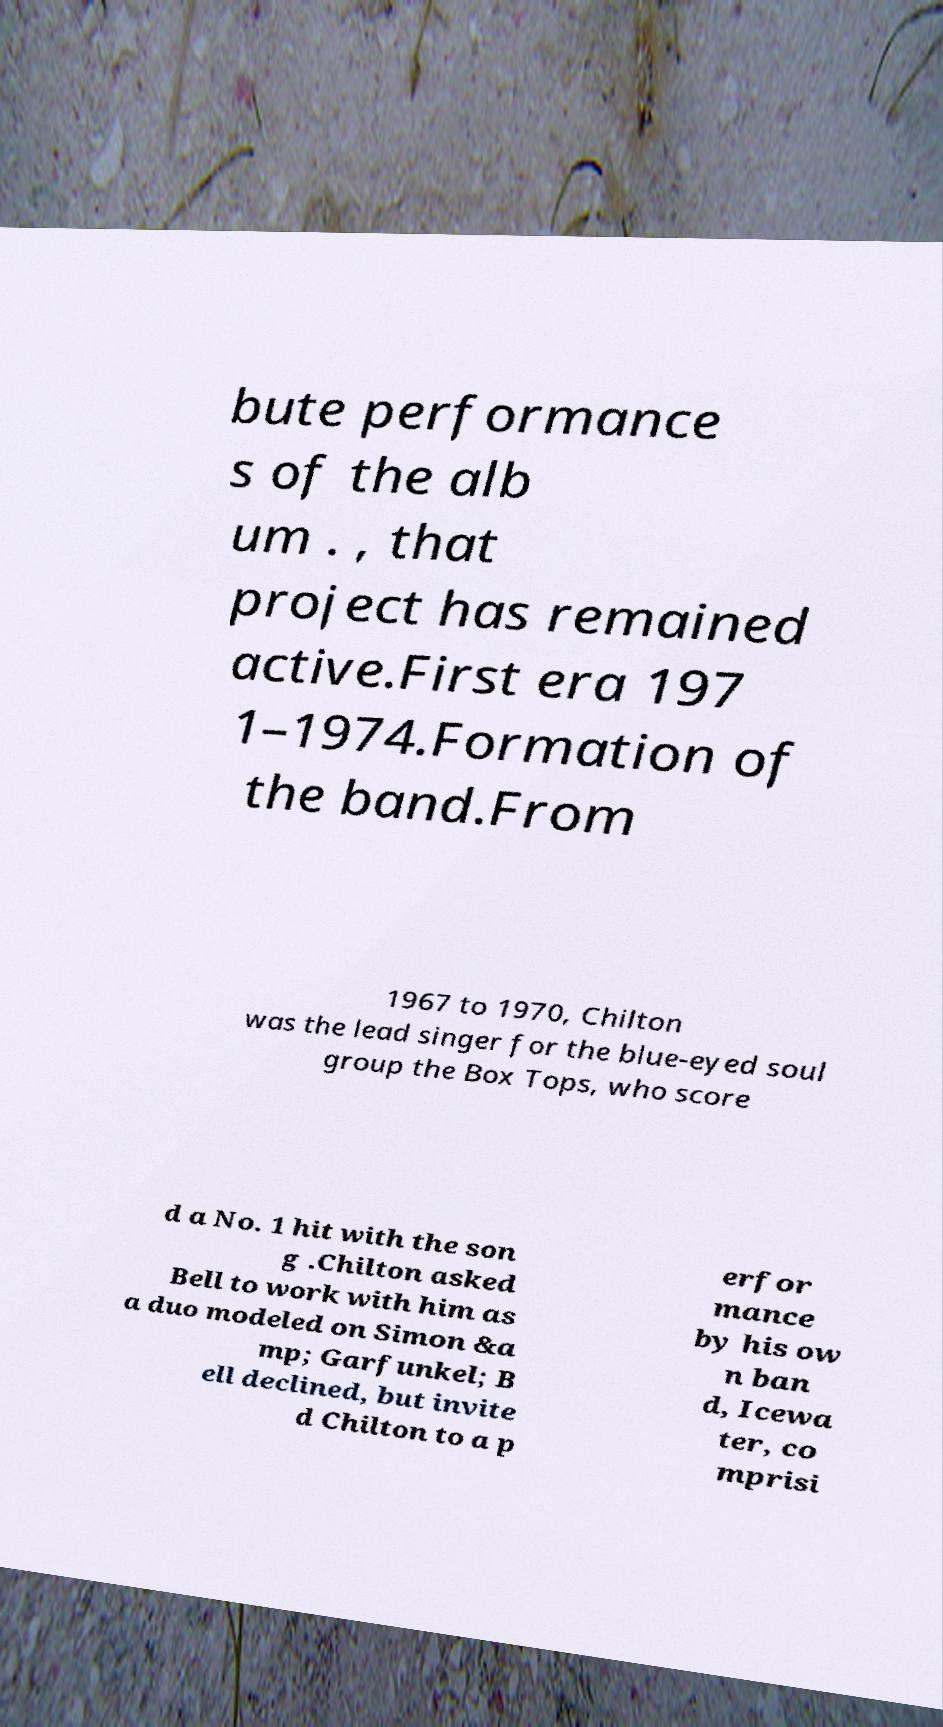Please read and relay the text visible in this image. What does it say? bute performance s of the alb um . , that project has remained active.First era 197 1–1974.Formation of the band.From 1967 to 1970, Chilton was the lead singer for the blue-eyed soul group the Box Tops, who score d a No. 1 hit with the son g .Chilton asked Bell to work with him as a duo modeled on Simon &a mp; Garfunkel; B ell declined, but invite d Chilton to a p erfor mance by his ow n ban d, Icewa ter, co mprisi 